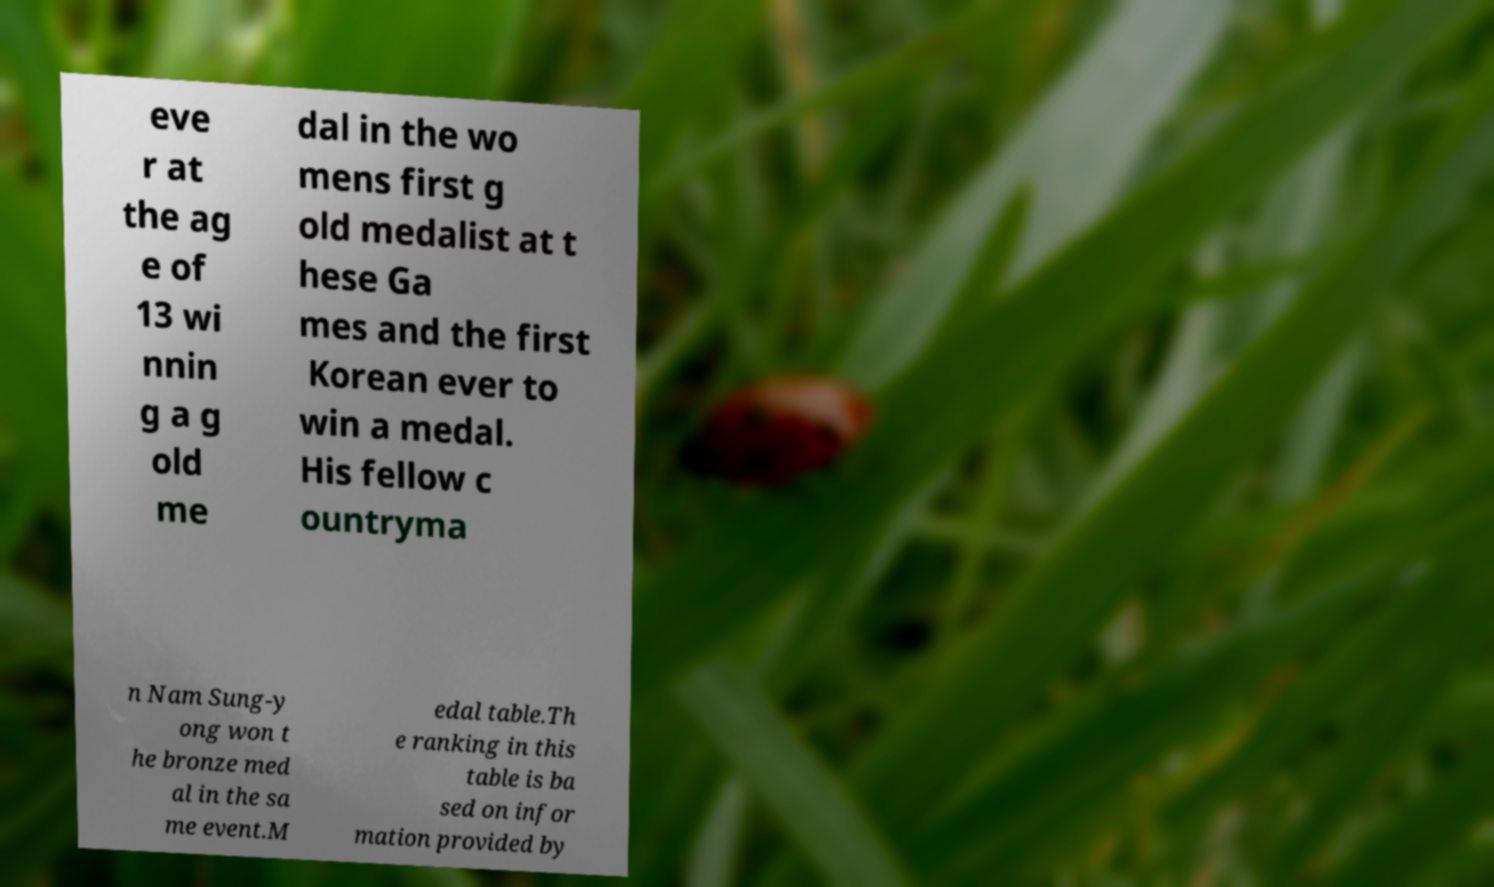What messages or text are displayed in this image? I need them in a readable, typed format. eve r at the ag e of 13 wi nnin g a g old me dal in the wo mens first g old medalist at t hese Ga mes and the first Korean ever to win a medal. His fellow c ountryma n Nam Sung-y ong won t he bronze med al in the sa me event.M edal table.Th e ranking in this table is ba sed on infor mation provided by 